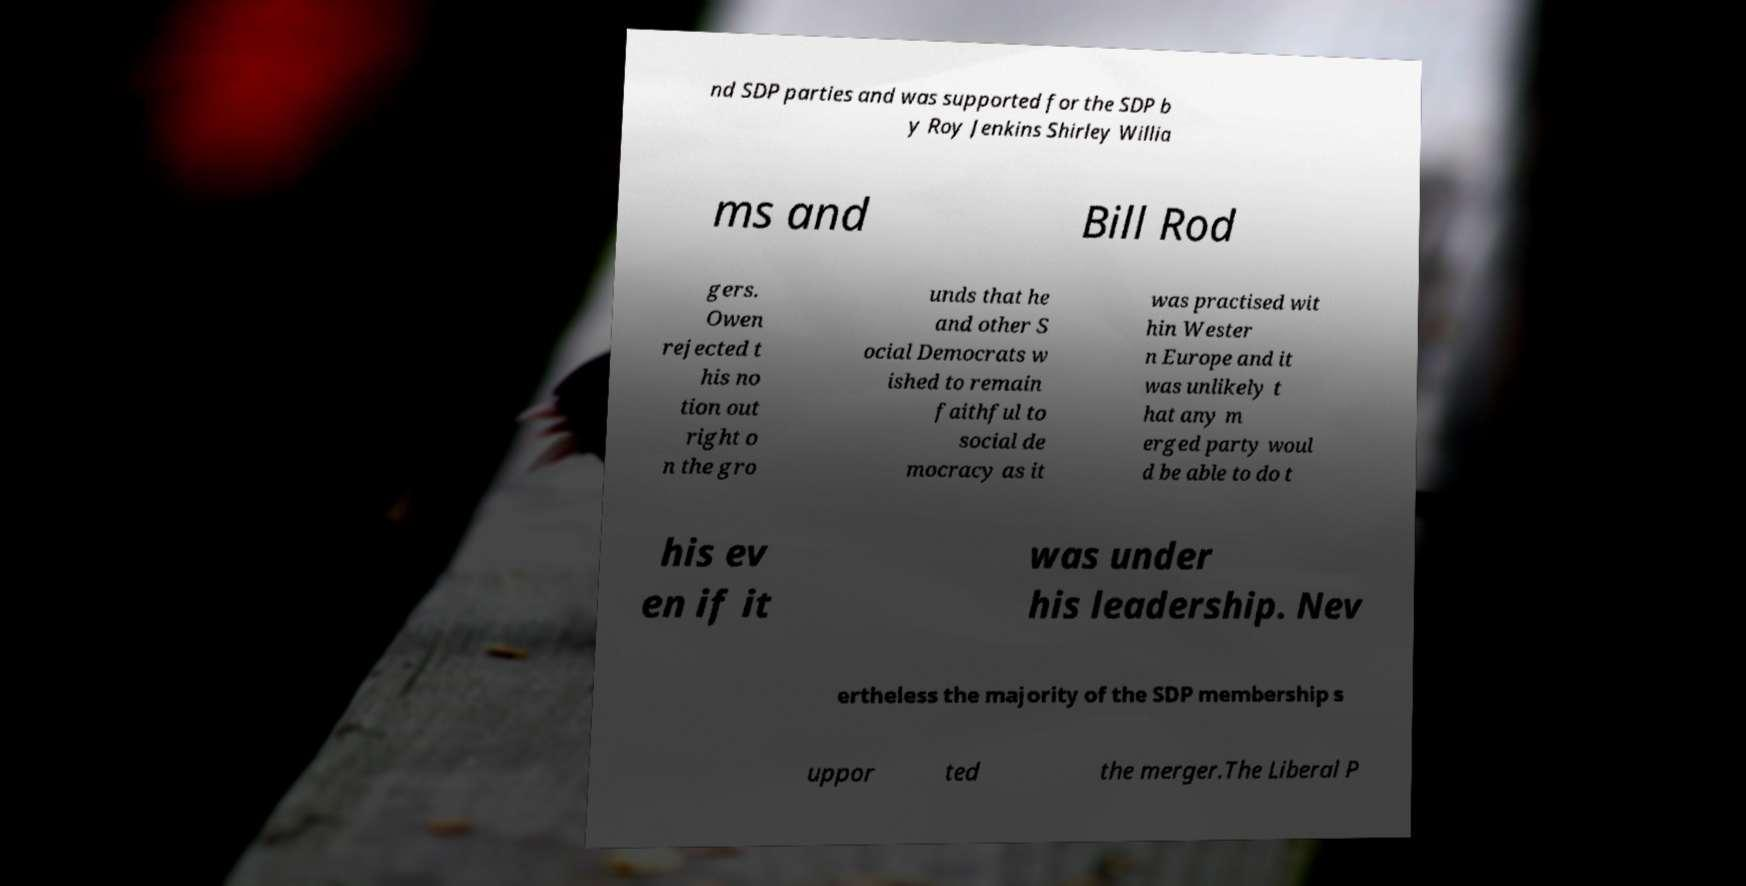Can you read and provide the text displayed in the image?This photo seems to have some interesting text. Can you extract and type it out for me? nd SDP parties and was supported for the SDP b y Roy Jenkins Shirley Willia ms and Bill Rod gers. Owen rejected t his no tion out right o n the gro unds that he and other S ocial Democrats w ished to remain faithful to social de mocracy as it was practised wit hin Wester n Europe and it was unlikely t hat any m erged party woul d be able to do t his ev en if it was under his leadership. Nev ertheless the majority of the SDP membership s uppor ted the merger.The Liberal P 